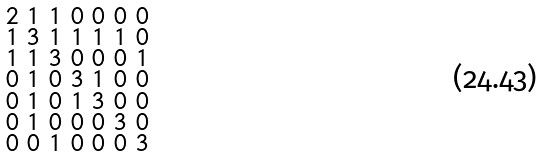Convert formula to latex. <formula><loc_0><loc_0><loc_500><loc_500>\begin{smallmatrix} 2 & 1 & 1 & 0 & 0 & 0 & 0 \\ 1 & 3 & 1 & 1 & 1 & 1 & 0 \\ 1 & 1 & 3 & 0 & 0 & 0 & 1 \\ 0 & 1 & 0 & 3 & 1 & 0 & 0 \\ 0 & 1 & 0 & 1 & 3 & 0 & 0 \\ 0 & 1 & 0 & 0 & 0 & 3 & 0 \\ 0 & 0 & 1 & 0 & 0 & 0 & 3 \end{smallmatrix}</formula> 